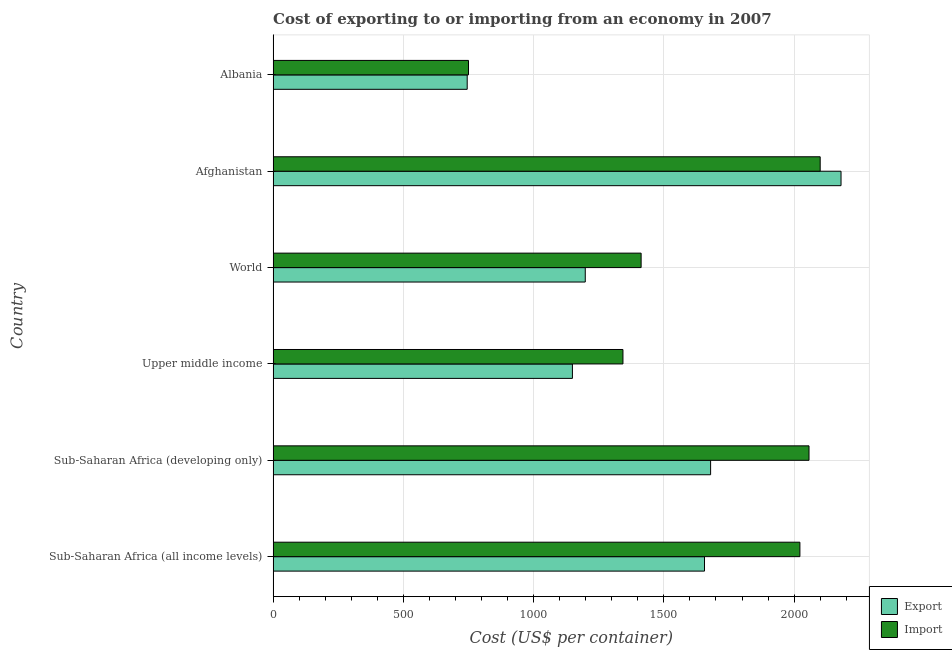How many groups of bars are there?
Keep it short and to the point. 6. Are the number of bars per tick equal to the number of legend labels?
Your answer should be very brief. Yes. How many bars are there on the 2nd tick from the bottom?
Keep it short and to the point. 2. What is the label of the 2nd group of bars from the top?
Make the answer very short. Afghanistan. What is the import cost in Sub-Saharan Africa (all income levels)?
Provide a short and direct response. 2022.13. Across all countries, what is the maximum export cost?
Keep it short and to the point. 2180. Across all countries, what is the minimum import cost?
Provide a succinct answer. 750. In which country was the export cost maximum?
Give a very brief answer. Afghanistan. In which country was the export cost minimum?
Provide a short and direct response. Albania. What is the total export cost in the graph?
Provide a short and direct response. 8607.31. What is the difference between the import cost in Afghanistan and that in Albania?
Provide a succinct answer. 1350. What is the difference between the import cost in World and the export cost in Sub-Saharan Africa (all income levels)?
Provide a short and direct response. -243.27. What is the average export cost per country?
Make the answer very short. 1434.55. What is the difference between the import cost and export cost in Sub-Saharan Africa (all income levels)?
Offer a terse response. 366.24. In how many countries, is the export cost greater than 100 US$?
Keep it short and to the point. 6. What is the ratio of the import cost in Albania to that in World?
Provide a short and direct response. 0.53. Is the difference between the import cost in Sub-Saharan Africa (all income levels) and World greater than the difference between the export cost in Sub-Saharan Africa (all income levels) and World?
Your answer should be compact. Yes. What is the difference between the highest and the second highest import cost?
Ensure brevity in your answer.  42.93. What is the difference between the highest and the lowest export cost?
Your response must be concise. 1435. What does the 2nd bar from the top in Sub-Saharan Africa (all income levels) represents?
Give a very brief answer. Export. What does the 1st bar from the bottom in Sub-Saharan Africa (developing only) represents?
Give a very brief answer. Export. How many bars are there?
Offer a terse response. 12. How many countries are there in the graph?
Keep it short and to the point. 6. Does the graph contain any zero values?
Make the answer very short. No. Does the graph contain grids?
Make the answer very short. Yes. Where does the legend appear in the graph?
Offer a very short reply. Bottom right. What is the title of the graph?
Offer a very short reply. Cost of exporting to or importing from an economy in 2007. What is the label or title of the X-axis?
Provide a short and direct response. Cost (US$ per container). What is the Cost (US$ per container) in Export in Sub-Saharan Africa (all income levels)?
Give a very brief answer. 1655.89. What is the Cost (US$ per container) in Import in Sub-Saharan Africa (all income levels)?
Offer a terse response. 2022.13. What is the Cost (US$ per container) of Export in Sub-Saharan Africa (developing only)?
Offer a very short reply. 1679.36. What is the Cost (US$ per container) of Import in Sub-Saharan Africa (developing only)?
Offer a very short reply. 2057.07. What is the Cost (US$ per container) in Export in Upper middle income?
Offer a very short reply. 1148.88. What is the Cost (US$ per container) in Import in Upper middle income?
Ensure brevity in your answer.  1342.85. What is the Cost (US$ per container) in Export in World?
Your response must be concise. 1198.18. What is the Cost (US$ per container) of Import in World?
Your answer should be very brief. 1412.62. What is the Cost (US$ per container) of Export in Afghanistan?
Keep it short and to the point. 2180. What is the Cost (US$ per container) in Import in Afghanistan?
Your answer should be very brief. 2100. What is the Cost (US$ per container) of Export in Albania?
Give a very brief answer. 745. What is the Cost (US$ per container) of Import in Albania?
Provide a succinct answer. 750. Across all countries, what is the maximum Cost (US$ per container) of Export?
Your answer should be compact. 2180. Across all countries, what is the maximum Cost (US$ per container) in Import?
Your answer should be compact. 2100. Across all countries, what is the minimum Cost (US$ per container) in Export?
Make the answer very short. 745. Across all countries, what is the minimum Cost (US$ per container) of Import?
Offer a very short reply. 750. What is the total Cost (US$ per container) in Export in the graph?
Your response must be concise. 8607.31. What is the total Cost (US$ per container) in Import in the graph?
Make the answer very short. 9684.67. What is the difference between the Cost (US$ per container) in Export in Sub-Saharan Africa (all income levels) and that in Sub-Saharan Africa (developing only)?
Make the answer very short. -23.47. What is the difference between the Cost (US$ per container) in Import in Sub-Saharan Africa (all income levels) and that in Sub-Saharan Africa (developing only)?
Your response must be concise. -34.94. What is the difference between the Cost (US$ per container) in Export in Sub-Saharan Africa (all income levels) and that in Upper middle income?
Provide a succinct answer. 507.02. What is the difference between the Cost (US$ per container) of Import in Sub-Saharan Africa (all income levels) and that in Upper middle income?
Give a very brief answer. 679.28. What is the difference between the Cost (US$ per container) of Export in Sub-Saharan Africa (all income levels) and that in World?
Keep it short and to the point. 457.71. What is the difference between the Cost (US$ per container) of Import in Sub-Saharan Africa (all income levels) and that in World?
Make the answer very short. 609.51. What is the difference between the Cost (US$ per container) in Export in Sub-Saharan Africa (all income levels) and that in Afghanistan?
Offer a terse response. -524.11. What is the difference between the Cost (US$ per container) in Import in Sub-Saharan Africa (all income levels) and that in Afghanistan?
Your answer should be compact. -77.87. What is the difference between the Cost (US$ per container) of Export in Sub-Saharan Africa (all income levels) and that in Albania?
Offer a very short reply. 910.89. What is the difference between the Cost (US$ per container) of Import in Sub-Saharan Africa (all income levels) and that in Albania?
Your answer should be very brief. 1272.13. What is the difference between the Cost (US$ per container) in Export in Sub-Saharan Africa (developing only) and that in Upper middle income?
Ensure brevity in your answer.  530.49. What is the difference between the Cost (US$ per container) of Import in Sub-Saharan Africa (developing only) and that in Upper middle income?
Your answer should be very brief. 714.21. What is the difference between the Cost (US$ per container) in Export in Sub-Saharan Africa (developing only) and that in World?
Your answer should be very brief. 481.18. What is the difference between the Cost (US$ per container) in Import in Sub-Saharan Africa (developing only) and that in World?
Provide a succinct answer. 644.45. What is the difference between the Cost (US$ per container) of Export in Sub-Saharan Africa (developing only) and that in Afghanistan?
Your answer should be very brief. -500.64. What is the difference between the Cost (US$ per container) of Import in Sub-Saharan Africa (developing only) and that in Afghanistan?
Provide a succinct answer. -42.93. What is the difference between the Cost (US$ per container) in Export in Sub-Saharan Africa (developing only) and that in Albania?
Offer a terse response. 934.36. What is the difference between the Cost (US$ per container) in Import in Sub-Saharan Africa (developing only) and that in Albania?
Offer a very short reply. 1307.07. What is the difference between the Cost (US$ per container) in Export in Upper middle income and that in World?
Make the answer very short. -49.31. What is the difference between the Cost (US$ per container) of Import in Upper middle income and that in World?
Offer a terse response. -69.76. What is the difference between the Cost (US$ per container) in Export in Upper middle income and that in Afghanistan?
Provide a succinct answer. -1031.12. What is the difference between the Cost (US$ per container) of Import in Upper middle income and that in Afghanistan?
Provide a short and direct response. -757.15. What is the difference between the Cost (US$ per container) in Export in Upper middle income and that in Albania?
Your answer should be very brief. 403.88. What is the difference between the Cost (US$ per container) in Import in Upper middle income and that in Albania?
Make the answer very short. 592.85. What is the difference between the Cost (US$ per container) of Export in World and that in Afghanistan?
Your answer should be compact. -981.82. What is the difference between the Cost (US$ per container) of Import in World and that in Afghanistan?
Provide a succinct answer. -687.38. What is the difference between the Cost (US$ per container) of Export in World and that in Albania?
Provide a succinct answer. 453.18. What is the difference between the Cost (US$ per container) in Import in World and that in Albania?
Your answer should be very brief. 662.62. What is the difference between the Cost (US$ per container) in Export in Afghanistan and that in Albania?
Keep it short and to the point. 1435. What is the difference between the Cost (US$ per container) of Import in Afghanistan and that in Albania?
Offer a terse response. 1350. What is the difference between the Cost (US$ per container) in Export in Sub-Saharan Africa (all income levels) and the Cost (US$ per container) in Import in Sub-Saharan Africa (developing only)?
Provide a short and direct response. -401.18. What is the difference between the Cost (US$ per container) in Export in Sub-Saharan Africa (all income levels) and the Cost (US$ per container) in Import in Upper middle income?
Your response must be concise. 313.04. What is the difference between the Cost (US$ per container) of Export in Sub-Saharan Africa (all income levels) and the Cost (US$ per container) of Import in World?
Your answer should be compact. 243.27. What is the difference between the Cost (US$ per container) of Export in Sub-Saharan Africa (all income levels) and the Cost (US$ per container) of Import in Afghanistan?
Your answer should be very brief. -444.11. What is the difference between the Cost (US$ per container) of Export in Sub-Saharan Africa (all income levels) and the Cost (US$ per container) of Import in Albania?
Give a very brief answer. 905.89. What is the difference between the Cost (US$ per container) in Export in Sub-Saharan Africa (developing only) and the Cost (US$ per container) in Import in Upper middle income?
Provide a succinct answer. 336.51. What is the difference between the Cost (US$ per container) of Export in Sub-Saharan Africa (developing only) and the Cost (US$ per container) of Import in World?
Make the answer very short. 266.74. What is the difference between the Cost (US$ per container) of Export in Sub-Saharan Africa (developing only) and the Cost (US$ per container) of Import in Afghanistan?
Offer a very short reply. -420.64. What is the difference between the Cost (US$ per container) of Export in Sub-Saharan Africa (developing only) and the Cost (US$ per container) of Import in Albania?
Your response must be concise. 929.36. What is the difference between the Cost (US$ per container) of Export in Upper middle income and the Cost (US$ per container) of Import in World?
Your answer should be compact. -263.74. What is the difference between the Cost (US$ per container) of Export in Upper middle income and the Cost (US$ per container) of Import in Afghanistan?
Ensure brevity in your answer.  -951.12. What is the difference between the Cost (US$ per container) in Export in Upper middle income and the Cost (US$ per container) in Import in Albania?
Your answer should be compact. 398.88. What is the difference between the Cost (US$ per container) in Export in World and the Cost (US$ per container) in Import in Afghanistan?
Offer a terse response. -901.82. What is the difference between the Cost (US$ per container) in Export in World and the Cost (US$ per container) in Import in Albania?
Your response must be concise. 448.18. What is the difference between the Cost (US$ per container) in Export in Afghanistan and the Cost (US$ per container) in Import in Albania?
Give a very brief answer. 1430. What is the average Cost (US$ per container) of Export per country?
Your answer should be compact. 1434.55. What is the average Cost (US$ per container) in Import per country?
Give a very brief answer. 1614.11. What is the difference between the Cost (US$ per container) of Export and Cost (US$ per container) of Import in Sub-Saharan Africa (all income levels)?
Make the answer very short. -366.24. What is the difference between the Cost (US$ per container) of Export and Cost (US$ per container) of Import in Sub-Saharan Africa (developing only)?
Ensure brevity in your answer.  -377.7. What is the difference between the Cost (US$ per container) in Export and Cost (US$ per container) in Import in Upper middle income?
Make the answer very short. -193.98. What is the difference between the Cost (US$ per container) in Export and Cost (US$ per container) in Import in World?
Give a very brief answer. -214.44. What is the difference between the Cost (US$ per container) of Export and Cost (US$ per container) of Import in Albania?
Ensure brevity in your answer.  -5. What is the ratio of the Cost (US$ per container) in Export in Sub-Saharan Africa (all income levels) to that in Upper middle income?
Keep it short and to the point. 1.44. What is the ratio of the Cost (US$ per container) of Import in Sub-Saharan Africa (all income levels) to that in Upper middle income?
Make the answer very short. 1.51. What is the ratio of the Cost (US$ per container) in Export in Sub-Saharan Africa (all income levels) to that in World?
Provide a short and direct response. 1.38. What is the ratio of the Cost (US$ per container) of Import in Sub-Saharan Africa (all income levels) to that in World?
Give a very brief answer. 1.43. What is the ratio of the Cost (US$ per container) in Export in Sub-Saharan Africa (all income levels) to that in Afghanistan?
Ensure brevity in your answer.  0.76. What is the ratio of the Cost (US$ per container) of Import in Sub-Saharan Africa (all income levels) to that in Afghanistan?
Your response must be concise. 0.96. What is the ratio of the Cost (US$ per container) of Export in Sub-Saharan Africa (all income levels) to that in Albania?
Offer a terse response. 2.22. What is the ratio of the Cost (US$ per container) in Import in Sub-Saharan Africa (all income levels) to that in Albania?
Offer a terse response. 2.7. What is the ratio of the Cost (US$ per container) of Export in Sub-Saharan Africa (developing only) to that in Upper middle income?
Provide a short and direct response. 1.46. What is the ratio of the Cost (US$ per container) in Import in Sub-Saharan Africa (developing only) to that in Upper middle income?
Provide a short and direct response. 1.53. What is the ratio of the Cost (US$ per container) of Export in Sub-Saharan Africa (developing only) to that in World?
Offer a very short reply. 1.4. What is the ratio of the Cost (US$ per container) of Import in Sub-Saharan Africa (developing only) to that in World?
Provide a short and direct response. 1.46. What is the ratio of the Cost (US$ per container) in Export in Sub-Saharan Africa (developing only) to that in Afghanistan?
Your answer should be compact. 0.77. What is the ratio of the Cost (US$ per container) of Import in Sub-Saharan Africa (developing only) to that in Afghanistan?
Your answer should be compact. 0.98. What is the ratio of the Cost (US$ per container) of Export in Sub-Saharan Africa (developing only) to that in Albania?
Your answer should be very brief. 2.25. What is the ratio of the Cost (US$ per container) in Import in Sub-Saharan Africa (developing only) to that in Albania?
Give a very brief answer. 2.74. What is the ratio of the Cost (US$ per container) of Export in Upper middle income to that in World?
Make the answer very short. 0.96. What is the ratio of the Cost (US$ per container) of Import in Upper middle income to that in World?
Keep it short and to the point. 0.95. What is the ratio of the Cost (US$ per container) of Export in Upper middle income to that in Afghanistan?
Make the answer very short. 0.53. What is the ratio of the Cost (US$ per container) of Import in Upper middle income to that in Afghanistan?
Your response must be concise. 0.64. What is the ratio of the Cost (US$ per container) in Export in Upper middle income to that in Albania?
Provide a short and direct response. 1.54. What is the ratio of the Cost (US$ per container) of Import in Upper middle income to that in Albania?
Ensure brevity in your answer.  1.79. What is the ratio of the Cost (US$ per container) of Export in World to that in Afghanistan?
Ensure brevity in your answer.  0.55. What is the ratio of the Cost (US$ per container) of Import in World to that in Afghanistan?
Give a very brief answer. 0.67. What is the ratio of the Cost (US$ per container) of Export in World to that in Albania?
Keep it short and to the point. 1.61. What is the ratio of the Cost (US$ per container) in Import in World to that in Albania?
Offer a terse response. 1.88. What is the ratio of the Cost (US$ per container) in Export in Afghanistan to that in Albania?
Ensure brevity in your answer.  2.93. What is the difference between the highest and the second highest Cost (US$ per container) of Export?
Give a very brief answer. 500.64. What is the difference between the highest and the second highest Cost (US$ per container) in Import?
Provide a short and direct response. 42.93. What is the difference between the highest and the lowest Cost (US$ per container) of Export?
Provide a succinct answer. 1435. What is the difference between the highest and the lowest Cost (US$ per container) in Import?
Keep it short and to the point. 1350. 